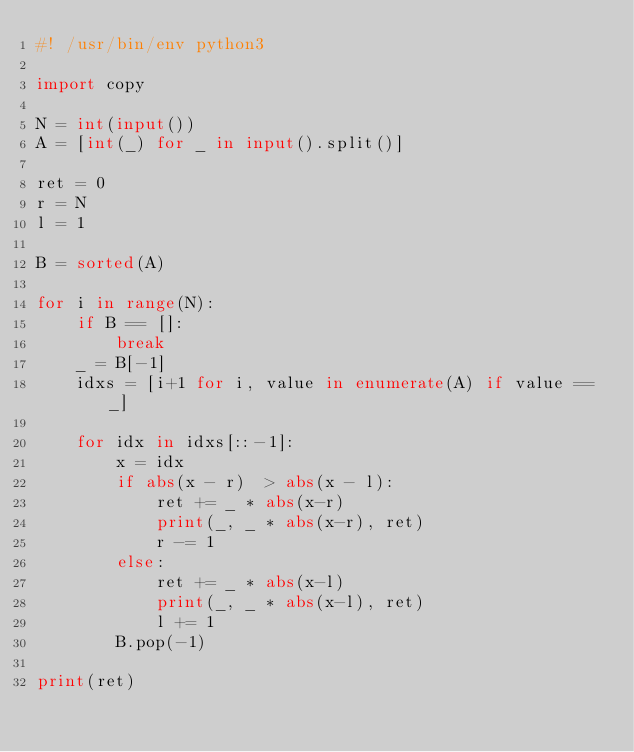Convert code to text. <code><loc_0><loc_0><loc_500><loc_500><_Python_>#! /usr/bin/env python3

import copy

N = int(input())
A = [int(_) for _ in input().split()]

ret = 0
r = N
l = 1

B = sorted(A)

for i in range(N):
    if B == []:
        break
    _ = B[-1]
    idxs = [i+1 for i, value in enumerate(A) if value == _]

    for idx in idxs[::-1]:
        x = idx
        if abs(x - r)  > abs(x - l):
            ret += _ * abs(x-r)
            print(_, _ * abs(x-r), ret)
            r -= 1
        else:
            ret += _ * abs(x-l)
            print(_, _ * abs(x-l), ret)
            l += 1
        B.pop(-1)

print(ret)</code> 